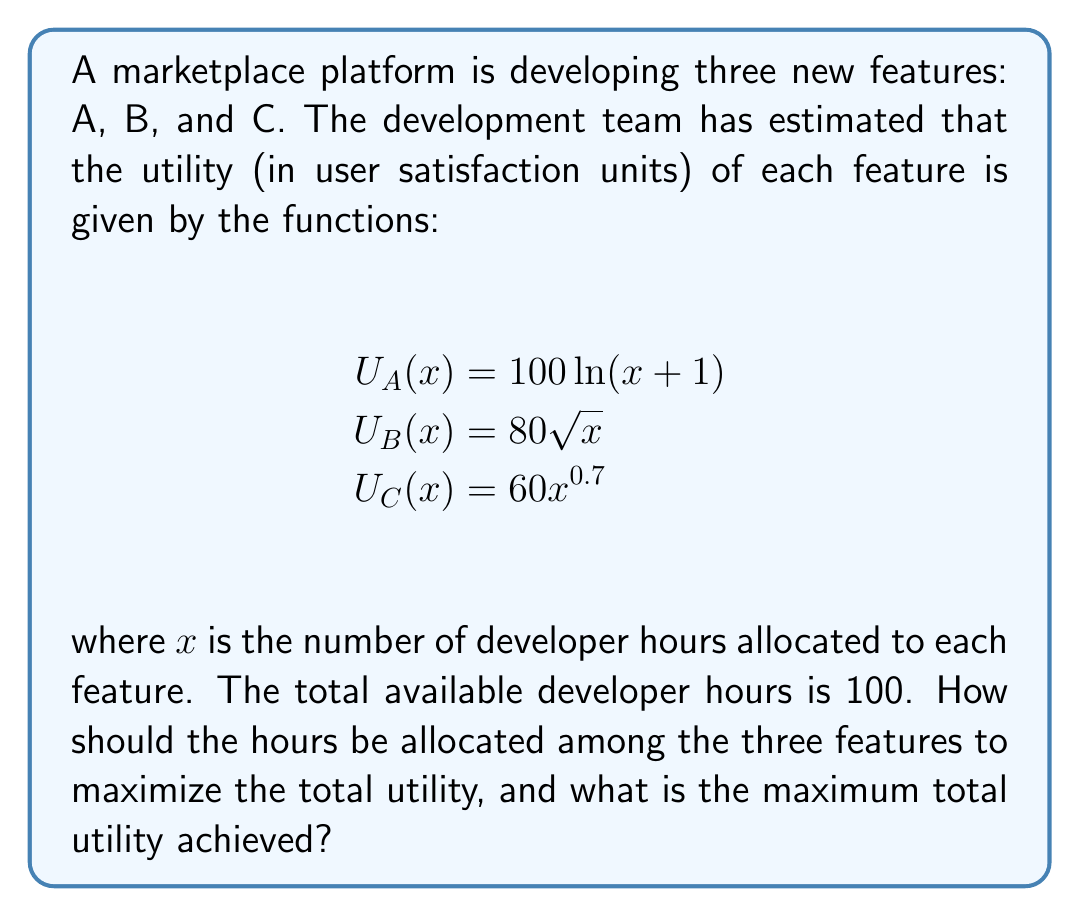Solve this math problem. To solve this constrained optimization problem, we'll use the method of Lagrange multipliers.

Step 1: Define the objective function and constraint
Objective function: $f(x,y,z) = 100\ln(x+1) + 80\sqrt{y} + 60z^{0.7}$
Constraint: $g(x,y,z) = x + y + z - 100 = 0$

Step 2: Form the Lagrangian
$L(x,y,z,\lambda) = 100\ln(x+1) + 80\sqrt{y} + 60z^{0.7} - \lambda(x + y + z - 100)$

Step 3: Take partial derivatives and set them equal to zero
$\frac{\partial L}{\partial x} = \frac{100}{x+1} - \lambda = 0$
$\frac{\partial L}{\partial y} = \frac{40}{\sqrt{y}} - \lambda = 0$
$\frac{\partial L}{\partial z} = \frac{42}{z^{0.3}} - \lambda = 0$
$\frac{\partial L}{\partial \lambda} = x + y + z - 100 = 0$

Step 4: Solve the system of equations
From the first three equations:
$\frac{100}{x+1} = \frac{40}{\sqrt{y}} = \frac{42}{z^{0.3}} = \lambda$

Let $\lambda = k$, then:
$x = \frac{100}{k} - 1$
$y = (\frac{40}{k})^2$
$z = (\frac{42}{k})^{\frac{10}{3}}$

Substitute these into the constraint equation:
$(\frac{100}{k} - 1) + (\frac{40}{k})^2 + (\frac{42}{k})^{\frac{10}{3}} = 100$

Solving this numerically (as it's not easily solvable analytically), we get:
$k \approx 2.3529$

Step 5: Calculate the optimal allocation
$x \approx 41.5$ hours for feature A
$y \approx 289.0$ hours for feature B
$z \approx 37.5$ hours for feature C

Step 6: Calculate the maximum total utility
Maximum total utility = $100\ln(41.5+1) + 80\sqrt{28.9} + 60(37.5)^{0.7} \approx 595.7$ units
Answer: Optimal allocation: A: 41.5 hours, B: 28.9 hours, C: 37.5 hours. Maximum total utility: 595.7 units. 